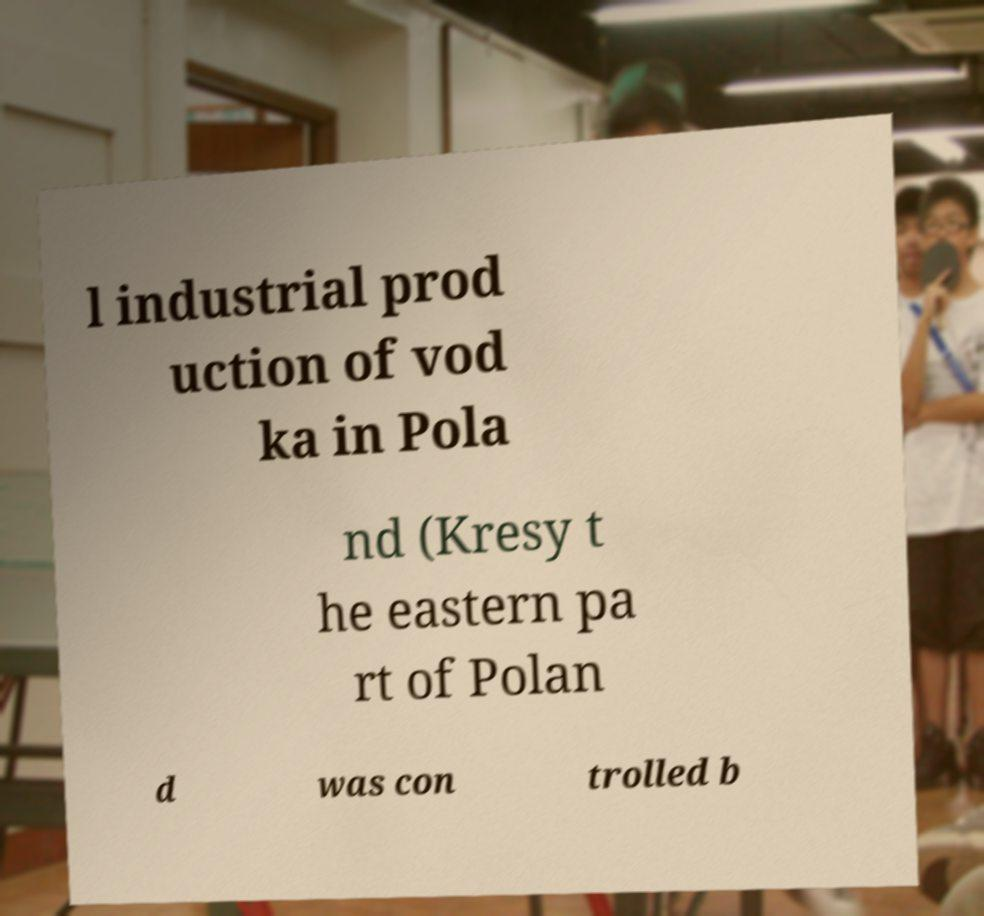Can you read and provide the text displayed in the image?This photo seems to have some interesting text. Can you extract and type it out for me? l industrial prod uction of vod ka in Pola nd (Kresy t he eastern pa rt of Polan d was con trolled b 